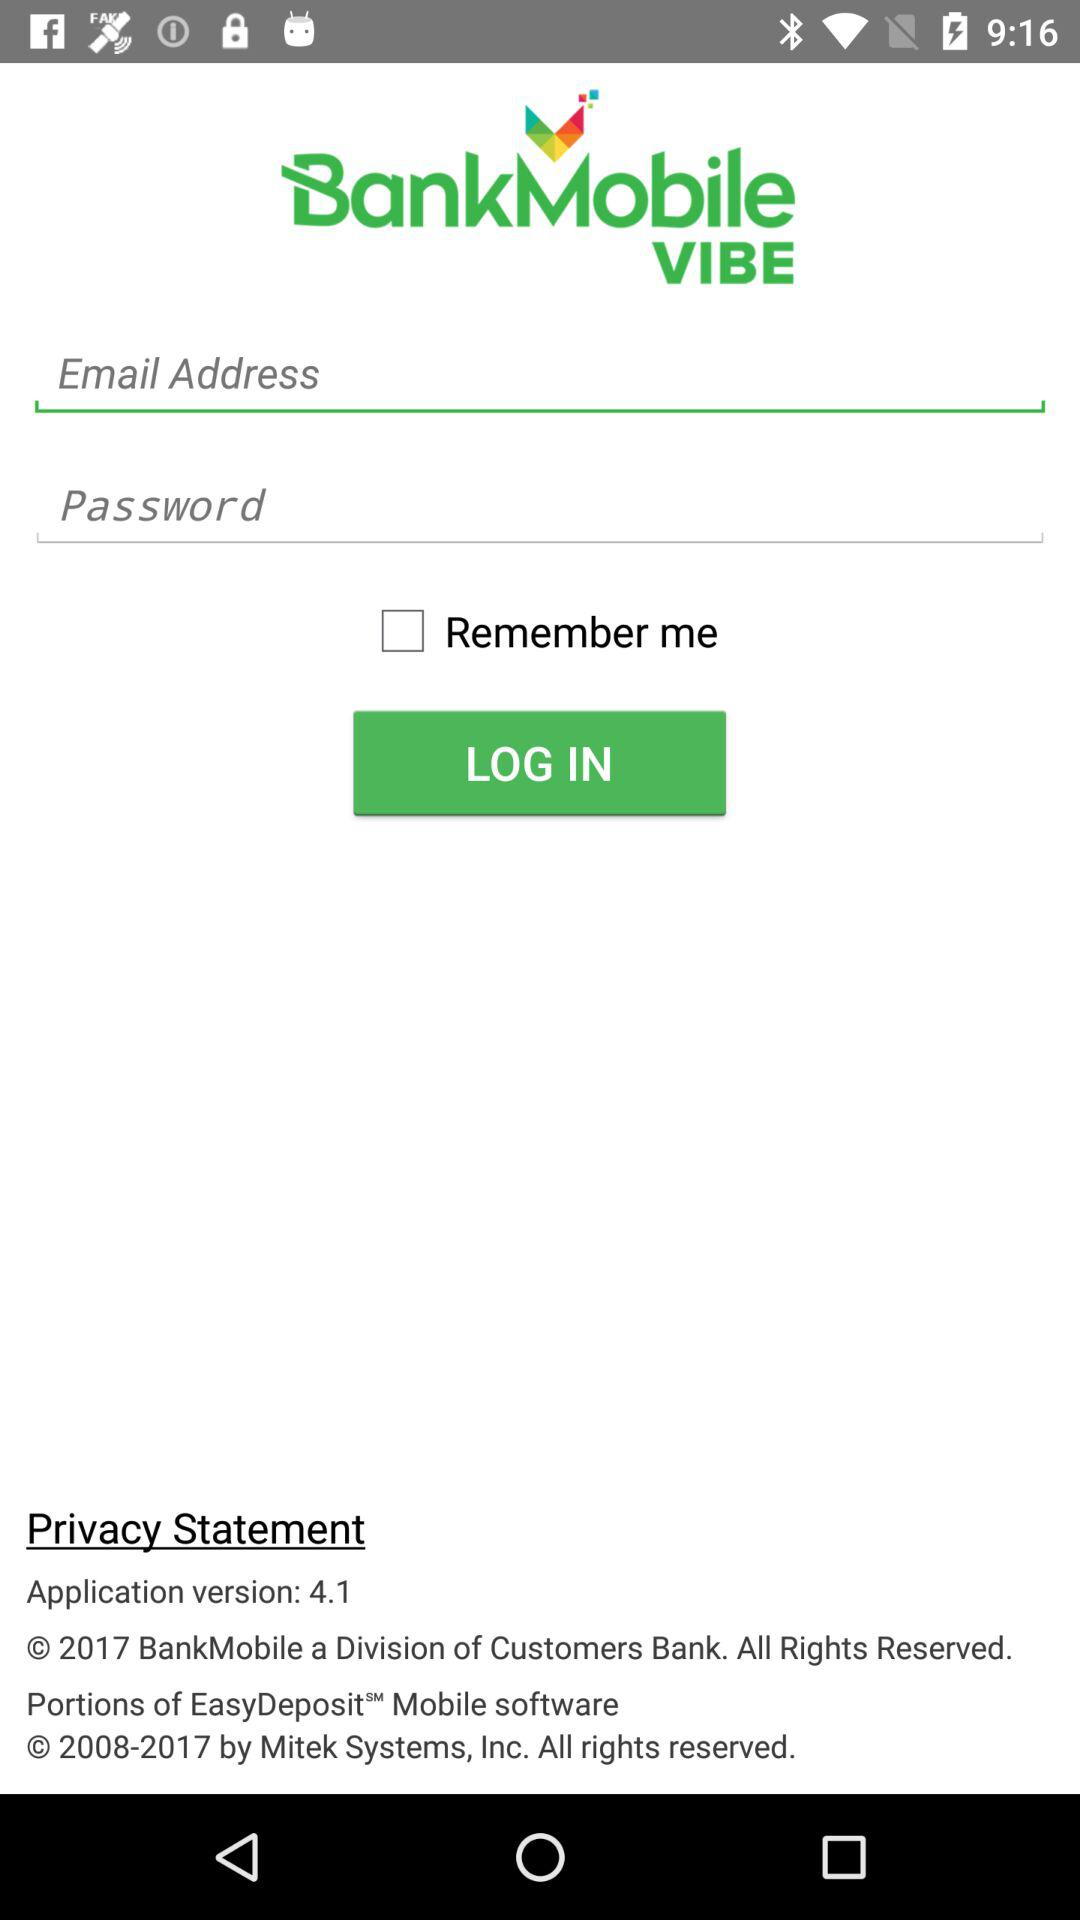How many text input fields are there in the login screen?
Answer the question using a single word or phrase. 2 